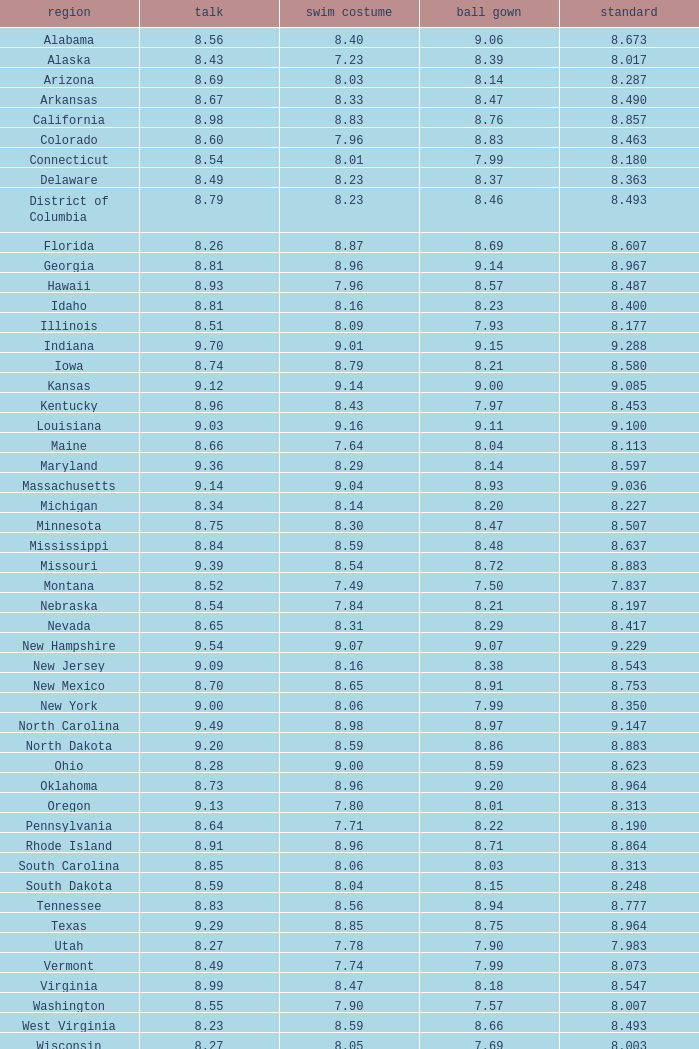Name the total number of swimsuits for evening gowns less than 8.21 and average of 8.453 with interview less than 9.09 1.0. 